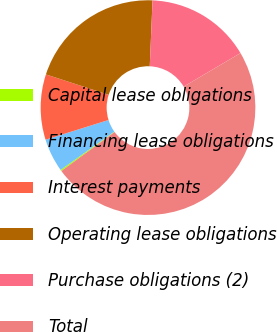Convert chart to OTSL. <chart><loc_0><loc_0><loc_500><loc_500><pie_chart><fcel>Capital lease obligations<fcel>Financing lease obligations<fcel>Interest payments<fcel>Operating lease obligations<fcel>Purchase obligations (2)<fcel>Total<nl><fcel>0.2%<fcel>5.02%<fcel>9.84%<fcel>20.67%<fcel>15.85%<fcel>48.43%<nl></chart> 